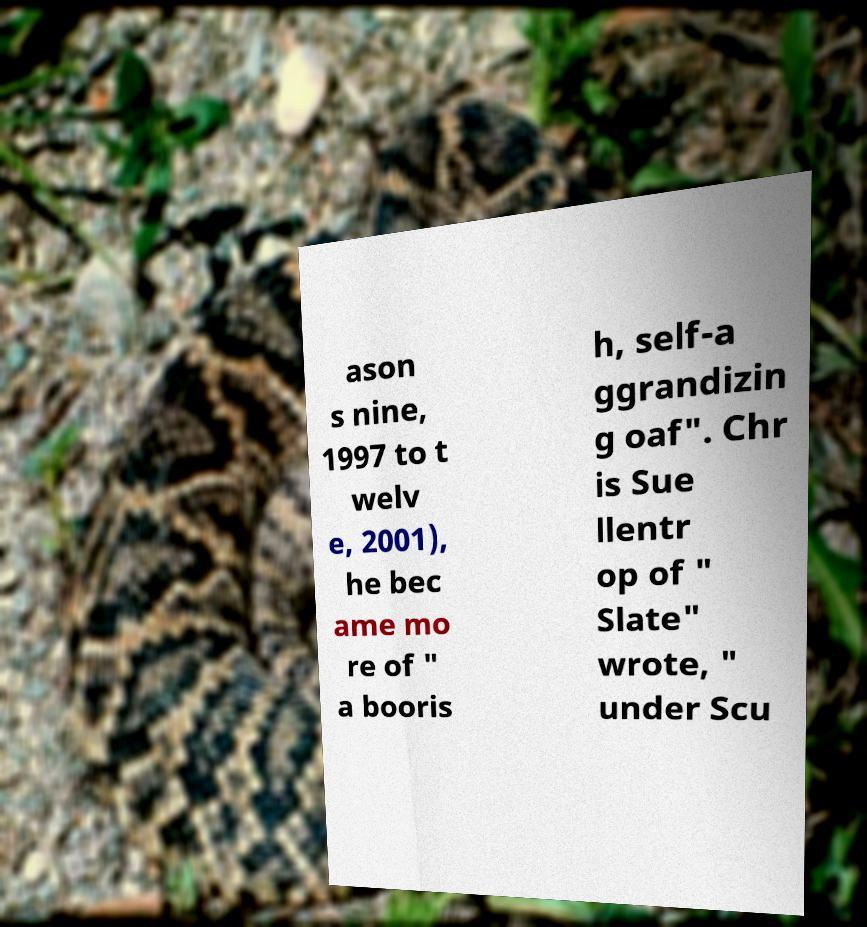Please read and relay the text visible in this image. What does it say? ason s nine, 1997 to t welv e, 2001), he bec ame mo re of " a booris h, self-a ggrandizin g oaf". Chr is Sue llentr op of " Slate" wrote, " under Scu 